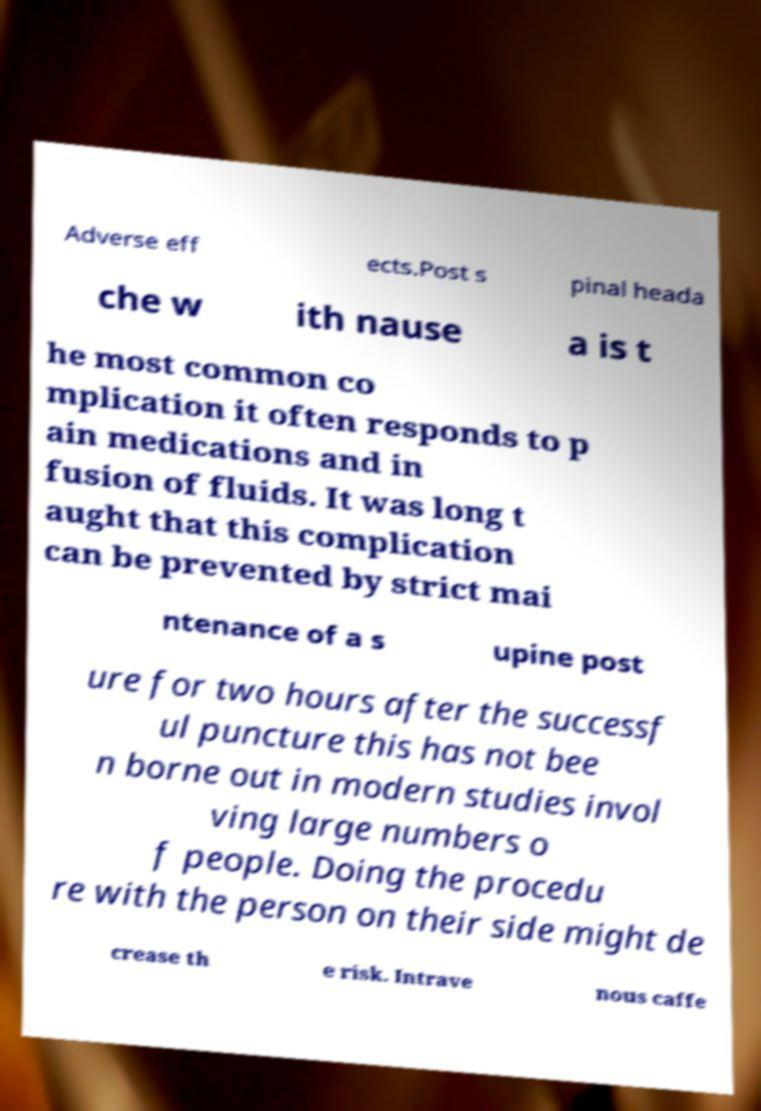For documentation purposes, I need the text within this image transcribed. Could you provide that? Adverse eff ects.Post s pinal heada che w ith nause a is t he most common co mplication it often responds to p ain medications and in fusion of fluids. It was long t aught that this complication can be prevented by strict mai ntenance of a s upine post ure for two hours after the successf ul puncture this has not bee n borne out in modern studies invol ving large numbers o f people. Doing the procedu re with the person on their side might de crease th e risk. Intrave nous caffe 